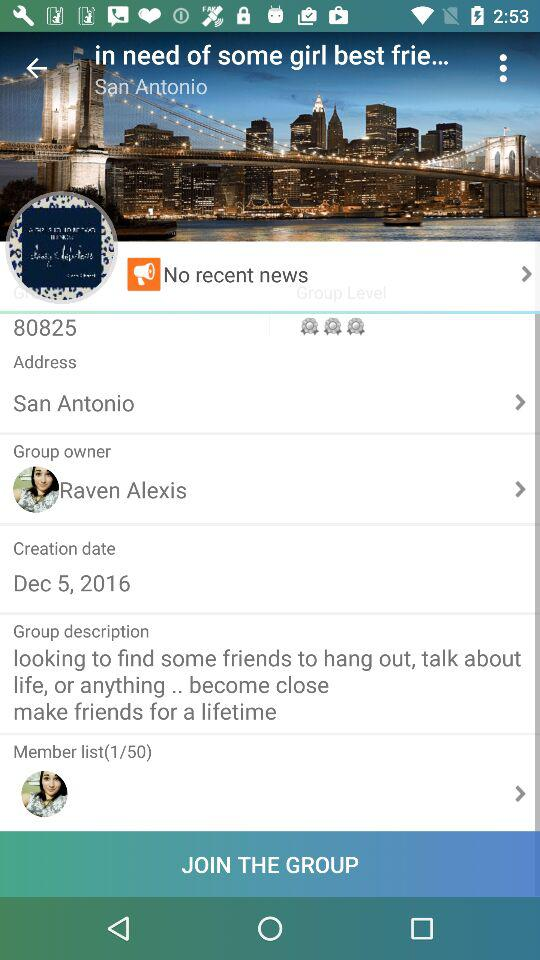What is the address? The address is "San Antonio". 